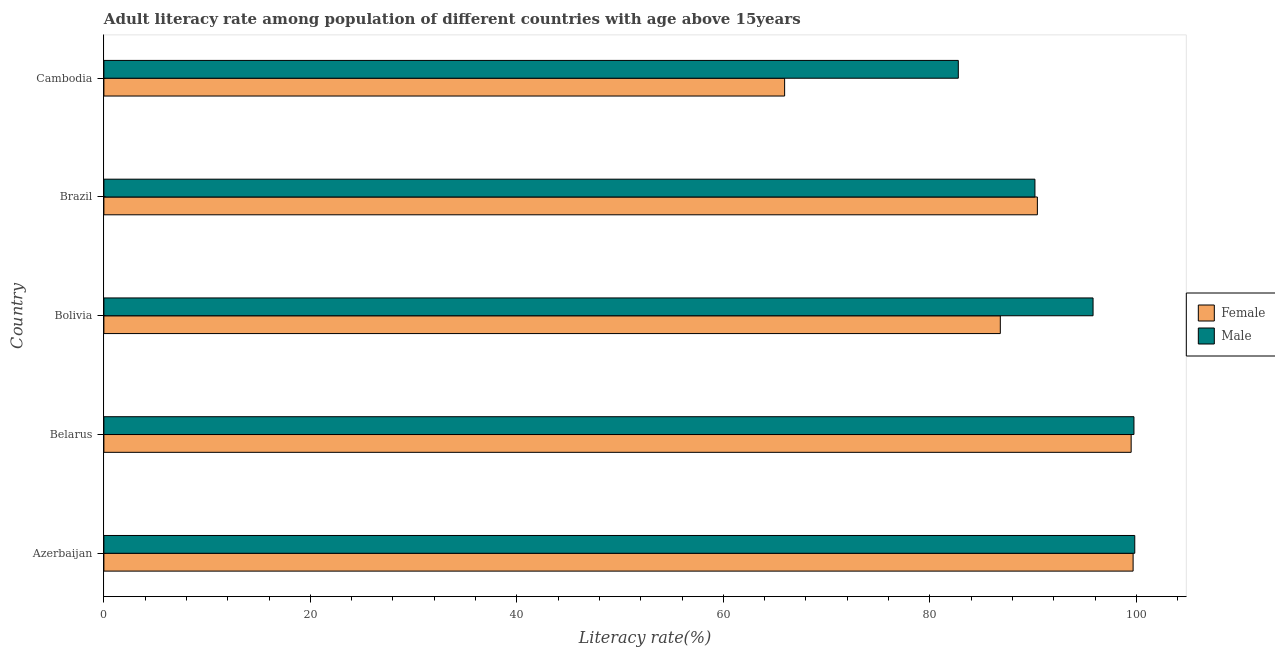How many different coloured bars are there?
Provide a succinct answer. 2. Are the number of bars per tick equal to the number of legend labels?
Keep it short and to the point. Yes. Are the number of bars on each tick of the Y-axis equal?
Provide a short and direct response. Yes. What is the label of the 3rd group of bars from the top?
Provide a short and direct response. Bolivia. What is the male adult literacy rate in Cambodia?
Your response must be concise. 82.75. Across all countries, what is the maximum female adult literacy rate?
Give a very brief answer. 99.68. Across all countries, what is the minimum female adult literacy rate?
Provide a short and direct response. 65.93. In which country was the male adult literacy rate maximum?
Offer a very short reply. Azerbaijan. In which country was the male adult literacy rate minimum?
Make the answer very short. Cambodia. What is the total male adult literacy rate in the graph?
Keep it short and to the point. 468.34. What is the difference between the female adult literacy rate in Brazil and that in Cambodia?
Ensure brevity in your answer.  24.48. What is the difference between the female adult literacy rate in Bolivia and the male adult literacy rate in Belarus?
Keep it short and to the point. -12.94. What is the average male adult literacy rate per country?
Give a very brief answer. 93.67. What is the difference between the male adult literacy rate and female adult literacy rate in Bolivia?
Ensure brevity in your answer.  8.98. In how many countries, is the female adult literacy rate greater than 8 %?
Keep it short and to the point. 5. What is the ratio of the female adult literacy rate in Bolivia to that in Cambodia?
Offer a terse response. 1.32. Is the difference between the female adult literacy rate in Brazil and Cambodia greater than the difference between the male adult literacy rate in Brazil and Cambodia?
Make the answer very short. Yes. What is the difference between the highest and the second highest female adult literacy rate?
Offer a very short reply. 0.19. What is the difference between the highest and the lowest male adult literacy rate?
Ensure brevity in your answer.  17.09. In how many countries, is the male adult literacy rate greater than the average male adult literacy rate taken over all countries?
Make the answer very short. 3. What does the 1st bar from the bottom in Azerbaijan represents?
Offer a terse response. Female. Are all the bars in the graph horizontal?
Provide a succinct answer. Yes. How many countries are there in the graph?
Keep it short and to the point. 5. Are the values on the major ticks of X-axis written in scientific E-notation?
Give a very brief answer. No. Does the graph contain any zero values?
Offer a very short reply. No. What is the title of the graph?
Give a very brief answer. Adult literacy rate among population of different countries with age above 15years. Does "From Government" appear as one of the legend labels in the graph?
Your response must be concise. No. What is the label or title of the X-axis?
Ensure brevity in your answer.  Literacy rate(%). What is the label or title of the Y-axis?
Your answer should be compact. Country. What is the Literacy rate(%) of Female in Azerbaijan?
Offer a terse response. 99.68. What is the Literacy rate(%) in Male in Azerbaijan?
Provide a short and direct response. 99.84. What is the Literacy rate(%) in Female in Belarus?
Your answer should be very brief. 99.49. What is the Literacy rate(%) in Male in Belarus?
Provide a short and direct response. 99.76. What is the Literacy rate(%) of Female in Bolivia?
Make the answer very short. 86.82. What is the Literacy rate(%) in Male in Bolivia?
Make the answer very short. 95.8. What is the Literacy rate(%) of Female in Brazil?
Your answer should be very brief. 90.41. What is the Literacy rate(%) in Male in Brazil?
Ensure brevity in your answer.  90.17. What is the Literacy rate(%) of Female in Cambodia?
Your answer should be compact. 65.93. What is the Literacy rate(%) of Male in Cambodia?
Offer a very short reply. 82.75. Across all countries, what is the maximum Literacy rate(%) of Female?
Your response must be concise. 99.68. Across all countries, what is the maximum Literacy rate(%) of Male?
Your response must be concise. 99.84. Across all countries, what is the minimum Literacy rate(%) of Female?
Provide a succinct answer. 65.93. Across all countries, what is the minimum Literacy rate(%) in Male?
Your answer should be very brief. 82.75. What is the total Literacy rate(%) in Female in the graph?
Keep it short and to the point. 442.34. What is the total Literacy rate(%) in Male in the graph?
Offer a very short reply. 468.34. What is the difference between the Literacy rate(%) of Female in Azerbaijan and that in Belarus?
Offer a terse response. 0.19. What is the difference between the Literacy rate(%) of Male in Azerbaijan and that in Belarus?
Give a very brief answer. 0.08. What is the difference between the Literacy rate(%) of Female in Azerbaijan and that in Bolivia?
Provide a succinct answer. 12.86. What is the difference between the Literacy rate(%) of Male in Azerbaijan and that in Bolivia?
Offer a terse response. 4.04. What is the difference between the Literacy rate(%) in Female in Azerbaijan and that in Brazil?
Keep it short and to the point. 9.27. What is the difference between the Literacy rate(%) in Male in Azerbaijan and that in Brazil?
Offer a very short reply. 9.67. What is the difference between the Literacy rate(%) in Female in Azerbaijan and that in Cambodia?
Provide a short and direct response. 33.75. What is the difference between the Literacy rate(%) in Male in Azerbaijan and that in Cambodia?
Give a very brief answer. 17.09. What is the difference between the Literacy rate(%) of Female in Belarus and that in Bolivia?
Your response must be concise. 12.67. What is the difference between the Literacy rate(%) in Male in Belarus and that in Bolivia?
Offer a terse response. 3.96. What is the difference between the Literacy rate(%) of Female in Belarus and that in Brazil?
Ensure brevity in your answer.  9.08. What is the difference between the Literacy rate(%) of Male in Belarus and that in Brazil?
Ensure brevity in your answer.  9.59. What is the difference between the Literacy rate(%) in Female in Belarus and that in Cambodia?
Provide a short and direct response. 33.56. What is the difference between the Literacy rate(%) in Male in Belarus and that in Cambodia?
Keep it short and to the point. 17.01. What is the difference between the Literacy rate(%) in Female in Bolivia and that in Brazil?
Provide a short and direct response. -3.59. What is the difference between the Literacy rate(%) of Male in Bolivia and that in Brazil?
Provide a short and direct response. 5.63. What is the difference between the Literacy rate(%) in Female in Bolivia and that in Cambodia?
Your answer should be very brief. 20.89. What is the difference between the Literacy rate(%) in Male in Bolivia and that in Cambodia?
Ensure brevity in your answer.  13.05. What is the difference between the Literacy rate(%) of Female in Brazil and that in Cambodia?
Make the answer very short. 24.48. What is the difference between the Literacy rate(%) in Male in Brazil and that in Cambodia?
Offer a terse response. 7.42. What is the difference between the Literacy rate(%) of Female in Azerbaijan and the Literacy rate(%) of Male in Belarus?
Give a very brief answer. -0.08. What is the difference between the Literacy rate(%) in Female in Azerbaijan and the Literacy rate(%) in Male in Bolivia?
Your answer should be compact. 3.88. What is the difference between the Literacy rate(%) in Female in Azerbaijan and the Literacy rate(%) in Male in Brazil?
Keep it short and to the point. 9.51. What is the difference between the Literacy rate(%) of Female in Azerbaijan and the Literacy rate(%) of Male in Cambodia?
Offer a very short reply. 16.93. What is the difference between the Literacy rate(%) in Female in Belarus and the Literacy rate(%) in Male in Bolivia?
Ensure brevity in your answer.  3.69. What is the difference between the Literacy rate(%) in Female in Belarus and the Literacy rate(%) in Male in Brazil?
Your answer should be compact. 9.32. What is the difference between the Literacy rate(%) in Female in Belarus and the Literacy rate(%) in Male in Cambodia?
Ensure brevity in your answer.  16.74. What is the difference between the Literacy rate(%) in Female in Bolivia and the Literacy rate(%) in Male in Brazil?
Make the answer very short. -3.35. What is the difference between the Literacy rate(%) in Female in Bolivia and the Literacy rate(%) in Male in Cambodia?
Ensure brevity in your answer.  4.07. What is the difference between the Literacy rate(%) of Female in Brazil and the Literacy rate(%) of Male in Cambodia?
Give a very brief answer. 7.66. What is the average Literacy rate(%) in Female per country?
Provide a short and direct response. 88.47. What is the average Literacy rate(%) in Male per country?
Your response must be concise. 93.67. What is the difference between the Literacy rate(%) of Female and Literacy rate(%) of Male in Azerbaijan?
Offer a terse response. -0.16. What is the difference between the Literacy rate(%) in Female and Literacy rate(%) in Male in Belarus?
Your response must be concise. -0.27. What is the difference between the Literacy rate(%) in Female and Literacy rate(%) in Male in Bolivia?
Offer a very short reply. -8.98. What is the difference between the Literacy rate(%) in Female and Literacy rate(%) in Male in Brazil?
Provide a short and direct response. 0.24. What is the difference between the Literacy rate(%) in Female and Literacy rate(%) in Male in Cambodia?
Make the answer very short. -16.82. What is the ratio of the Literacy rate(%) of Female in Azerbaijan to that in Bolivia?
Keep it short and to the point. 1.15. What is the ratio of the Literacy rate(%) in Male in Azerbaijan to that in Bolivia?
Keep it short and to the point. 1.04. What is the ratio of the Literacy rate(%) of Female in Azerbaijan to that in Brazil?
Your answer should be compact. 1.1. What is the ratio of the Literacy rate(%) in Male in Azerbaijan to that in Brazil?
Keep it short and to the point. 1.11. What is the ratio of the Literacy rate(%) of Female in Azerbaijan to that in Cambodia?
Your answer should be very brief. 1.51. What is the ratio of the Literacy rate(%) of Male in Azerbaijan to that in Cambodia?
Your answer should be very brief. 1.21. What is the ratio of the Literacy rate(%) of Female in Belarus to that in Bolivia?
Provide a short and direct response. 1.15. What is the ratio of the Literacy rate(%) of Male in Belarus to that in Bolivia?
Your response must be concise. 1.04. What is the ratio of the Literacy rate(%) of Female in Belarus to that in Brazil?
Your answer should be very brief. 1.1. What is the ratio of the Literacy rate(%) of Male in Belarus to that in Brazil?
Provide a short and direct response. 1.11. What is the ratio of the Literacy rate(%) in Female in Belarus to that in Cambodia?
Offer a very short reply. 1.51. What is the ratio of the Literacy rate(%) in Male in Belarus to that in Cambodia?
Make the answer very short. 1.21. What is the ratio of the Literacy rate(%) of Female in Bolivia to that in Brazil?
Keep it short and to the point. 0.96. What is the ratio of the Literacy rate(%) of Male in Bolivia to that in Brazil?
Keep it short and to the point. 1.06. What is the ratio of the Literacy rate(%) in Female in Bolivia to that in Cambodia?
Your response must be concise. 1.32. What is the ratio of the Literacy rate(%) in Male in Bolivia to that in Cambodia?
Your answer should be very brief. 1.16. What is the ratio of the Literacy rate(%) in Female in Brazil to that in Cambodia?
Your answer should be very brief. 1.37. What is the ratio of the Literacy rate(%) in Male in Brazil to that in Cambodia?
Offer a very short reply. 1.09. What is the difference between the highest and the second highest Literacy rate(%) of Female?
Offer a very short reply. 0.19. What is the difference between the highest and the second highest Literacy rate(%) of Male?
Your answer should be very brief. 0.08. What is the difference between the highest and the lowest Literacy rate(%) of Female?
Keep it short and to the point. 33.75. What is the difference between the highest and the lowest Literacy rate(%) of Male?
Provide a succinct answer. 17.09. 